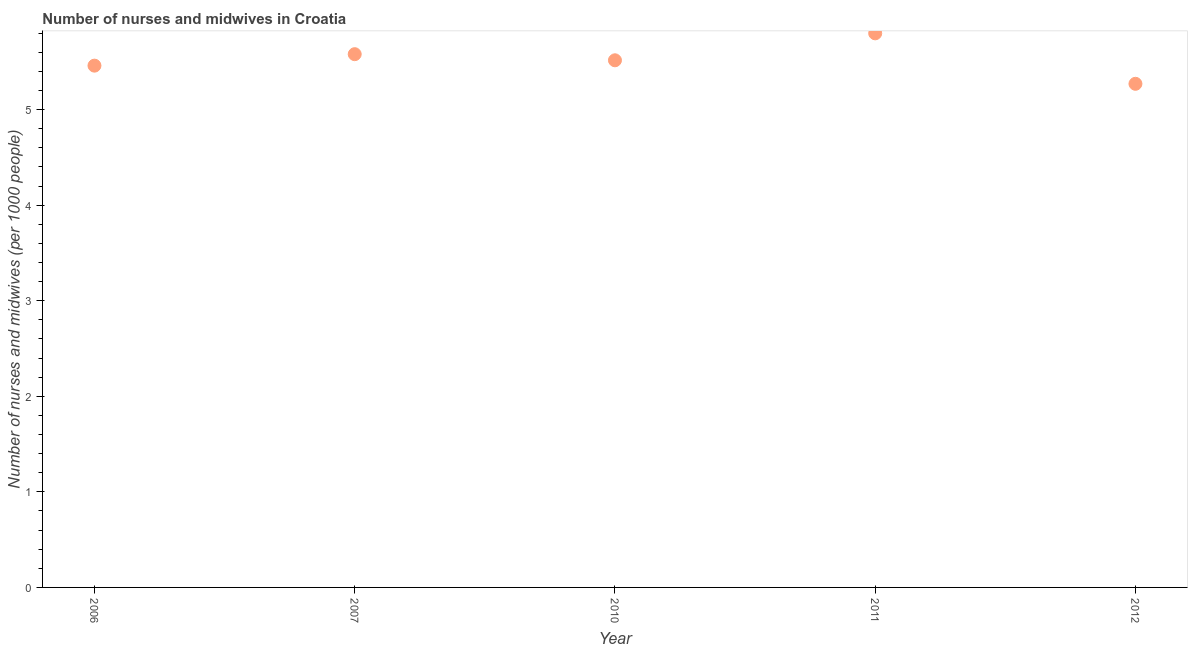What is the number of nurses and midwives in 2011?
Keep it short and to the point. 5.8. Across all years, what is the maximum number of nurses and midwives?
Give a very brief answer. 5.8. Across all years, what is the minimum number of nurses and midwives?
Provide a short and direct response. 5.27. In which year was the number of nurses and midwives maximum?
Provide a short and direct response. 2011. What is the sum of the number of nurses and midwives?
Your response must be concise. 27.62. What is the difference between the number of nurses and midwives in 2006 and 2007?
Offer a terse response. -0.12. What is the average number of nurses and midwives per year?
Your answer should be very brief. 5.52. What is the median number of nurses and midwives?
Offer a very short reply. 5.52. In how many years, is the number of nurses and midwives greater than 5.6 ?
Make the answer very short. 1. Do a majority of the years between 2006 and 2010 (inclusive) have number of nurses and midwives greater than 3.2 ?
Your answer should be compact. Yes. What is the ratio of the number of nurses and midwives in 2006 to that in 2007?
Ensure brevity in your answer.  0.98. Is the number of nurses and midwives in 2007 less than that in 2012?
Provide a short and direct response. No. What is the difference between the highest and the second highest number of nurses and midwives?
Provide a short and direct response. 0.22. Is the sum of the number of nurses and midwives in 2007 and 2010 greater than the maximum number of nurses and midwives across all years?
Provide a short and direct response. Yes. What is the difference between the highest and the lowest number of nurses and midwives?
Give a very brief answer. 0.53. In how many years, is the number of nurses and midwives greater than the average number of nurses and midwives taken over all years?
Provide a short and direct response. 2. Does the number of nurses and midwives monotonically increase over the years?
Provide a succinct answer. No. How many dotlines are there?
Your response must be concise. 1. What is the difference between two consecutive major ticks on the Y-axis?
Give a very brief answer. 1. Are the values on the major ticks of Y-axis written in scientific E-notation?
Offer a very short reply. No. Does the graph contain any zero values?
Your answer should be compact. No. What is the title of the graph?
Your response must be concise. Number of nurses and midwives in Croatia. What is the label or title of the Y-axis?
Provide a short and direct response. Number of nurses and midwives (per 1000 people). What is the Number of nurses and midwives (per 1000 people) in 2006?
Offer a very short reply. 5.46. What is the Number of nurses and midwives (per 1000 people) in 2007?
Keep it short and to the point. 5.58. What is the Number of nurses and midwives (per 1000 people) in 2010?
Give a very brief answer. 5.52. What is the Number of nurses and midwives (per 1000 people) in 2011?
Give a very brief answer. 5.8. What is the Number of nurses and midwives (per 1000 people) in 2012?
Your answer should be very brief. 5.27. What is the difference between the Number of nurses and midwives (per 1000 people) in 2006 and 2007?
Your answer should be very brief. -0.12. What is the difference between the Number of nurses and midwives (per 1000 people) in 2006 and 2010?
Your response must be concise. -0.06. What is the difference between the Number of nurses and midwives (per 1000 people) in 2006 and 2011?
Keep it short and to the point. -0.34. What is the difference between the Number of nurses and midwives (per 1000 people) in 2006 and 2012?
Your answer should be very brief. 0.19. What is the difference between the Number of nurses and midwives (per 1000 people) in 2007 and 2010?
Your answer should be compact. 0.06. What is the difference between the Number of nurses and midwives (per 1000 people) in 2007 and 2011?
Keep it short and to the point. -0.22. What is the difference between the Number of nurses and midwives (per 1000 people) in 2007 and 2012?
Ensure brevity in your answer.  0.31. What is the difference between the Number of nurses and midwives (per 1000 people) in 2010 and 2011?
Your answer should be compact. -0.28. What is the difference between the Number of nurses and midwives (per 1000 people) in 2010 and 2012?
Offer a very short reply. 0.25. What is the difference between the Number of nurses and midwives (per 1000 people) in 2011 and 2012?
Give a very brief answer. 0.53. What is the ratio of the Number of nurses and midwives (per 1000 people) in 2006 to that in 2007?
Your response must be concise. 0.98. What is the ratio of the Number of nurses and midwives (per 1000 people) in 2006 to that in 2010?
Make the answer very short. 0.99. What is the ratio of the Number of nurses and midwives (per 1000 people) in 2006 to that in 2011?
Offer a very short reply. 0.94. What is the ratio of the Number of nurses and midwives (per 1000 people) in 2006 to that in 2012?
Your answer should be compact. 1.04. What is the ratio of the Number of nurses and midwives (per 1000 people) in 2007 to that in 2012?
Offer a terse response. 1.06. What is the ratio of the Number of nurses and midwives (per 1000 people) in 2010 to that in 2011?
Your response must be concise. 0.95. What is the ratio of the Number of nurses and midwives (per 1000 people) in 2010 to that in 2012?
Offer a terse response. 1.05. 